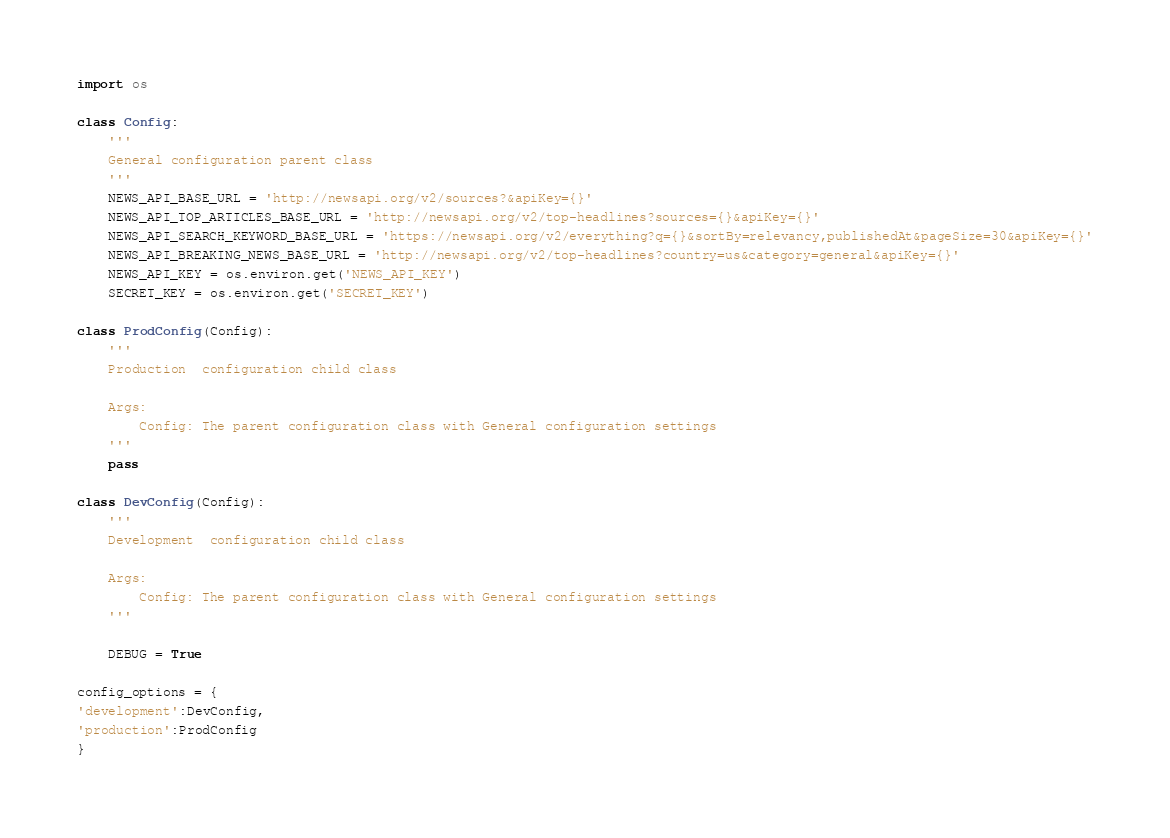Convert code to text. <code><loc_0><loc_0><loc_500><loc_500><_Python_>import os

class Config:
    '''
    General configuration parent class
    '''
    NEWS_API_BASE_URL = 'http://newsapi.org/v2/sources?&apiKey={}'
    NEWS_API_TOP_ARTICLES_BASE_URL = 'http://newsapi.org/v2/top-headlines?sources={}&apiKey={}'
    NEWS_API_SEARCH_KEYWORD_BASE_URL = 'https://newsapi.org/v2/everything?q={}&sortBy=relevancy,publishedAt&pageSize=30&apiKey={}'
    NEWS_API_BREAKING_NEWS_BASE_URL = 'http://newsapi.org/v2/top-headlines?country=us&category=general&apiKey={}'
    NEWS_API_KEY = os.environ.get('NEWS_API_KEY')
    SECRET_KEY = os.environ.get('SECRET_KEY') 

class ProdConfig(Config):
    '''
    Production  configuration child class

    Args:
        Config: The parent configuration class with General configuration settings
    '''
    pass

class DevConfig(Config):
    '''
    Development  configuration child class

    Args:
        Config: The parent configuration class with General configuration settings
    '''

    DEBUG = True

config_options = {
'development':DevConfig,
'production':ProdConfig
}
</code> 